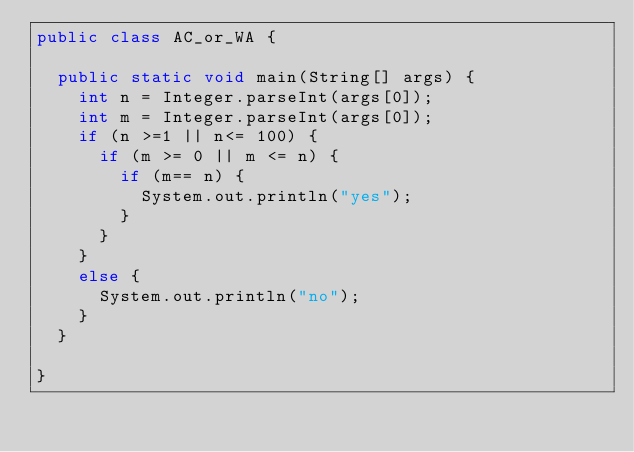<code> <loc_0><loc_0><loc_500><loc_500><_Java_>public class AC_or_WA {

	public static void main(String[] args) {
		int n = Integer.parseInt(args[0]);
		int m = Integer.parseInt(args[0]);
		if (n >=1 || n<= 100) {
			if (m >= 0 || m <= n) {
				if (m== n) {
					System.out.println("yes");
				}
			}
		}
		else {
			System.out.println("no");
		}
	}

}</code> 